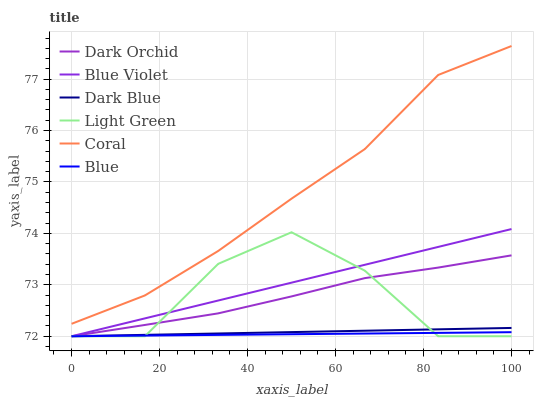Does Blue have the minimum area under the curve?
Answer yes or no. Yes. Does Coral have the maximum area under the curve?
Answer yes or no. Yes. Does Dark Orchid have the minimum area under the curve?
Answer yes or no. No. Does Dark Orchid have the maximum area under the curve?
Answer yes or no. No. Is Blue the smoothest?
Answer yes or no. Yes. Is Light Green the roughest?
Answer yes or no. Yes. Is Coral the smoothest?
Answer yes or no. No. Is Coral the roughest?
Answer yes or no. No. Does Blue have the lowest value?
Answer yes or no. Yes. Does Coral have the lowest value?
Answer yes or no. No. Does Coral have the highest value?
Answer yes or no. Yes. Does Dark Orchid have the highest value?
Answer yes or no. No. Is Dark Orchid less than Coral?
Answer yes or no. Yes. Is Coral greater than Dark Orchid?
Answer yes or no. Yes. Does Dark Blue intersect Dark Orchid?
Answer yes or no. Yes. Is Dark Blue less than Dark Orchid?
Answer yes or no. No. Is Dark Blue greater than Dark Orchid?
Answer yes or no. No. Does Dark Orchid intersect Coral?
Answer yes or no. No. 